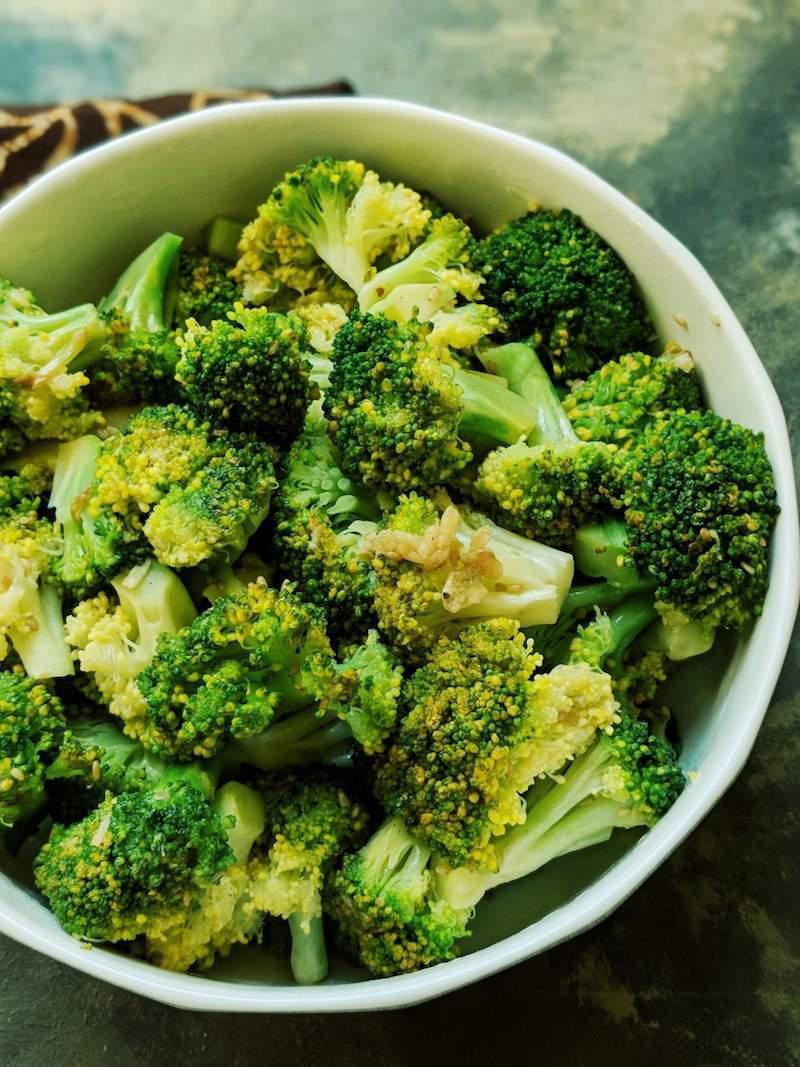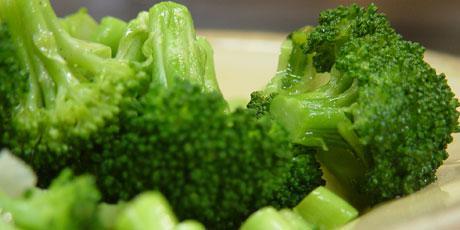The first image is the image on the left, the second image is the image on the right. Evaluate the accuracy of this statement regarding the images: "The left and right image contains the same number of white plates with broccoli.". Is it true? Answer yes or no. Yes. The first image is the image on the left, the second image is the image on the right. Considering the images on both sides, is "In one image, broccoli florets are being steamed in a metal pot." valid? Answer yes or no. No. 